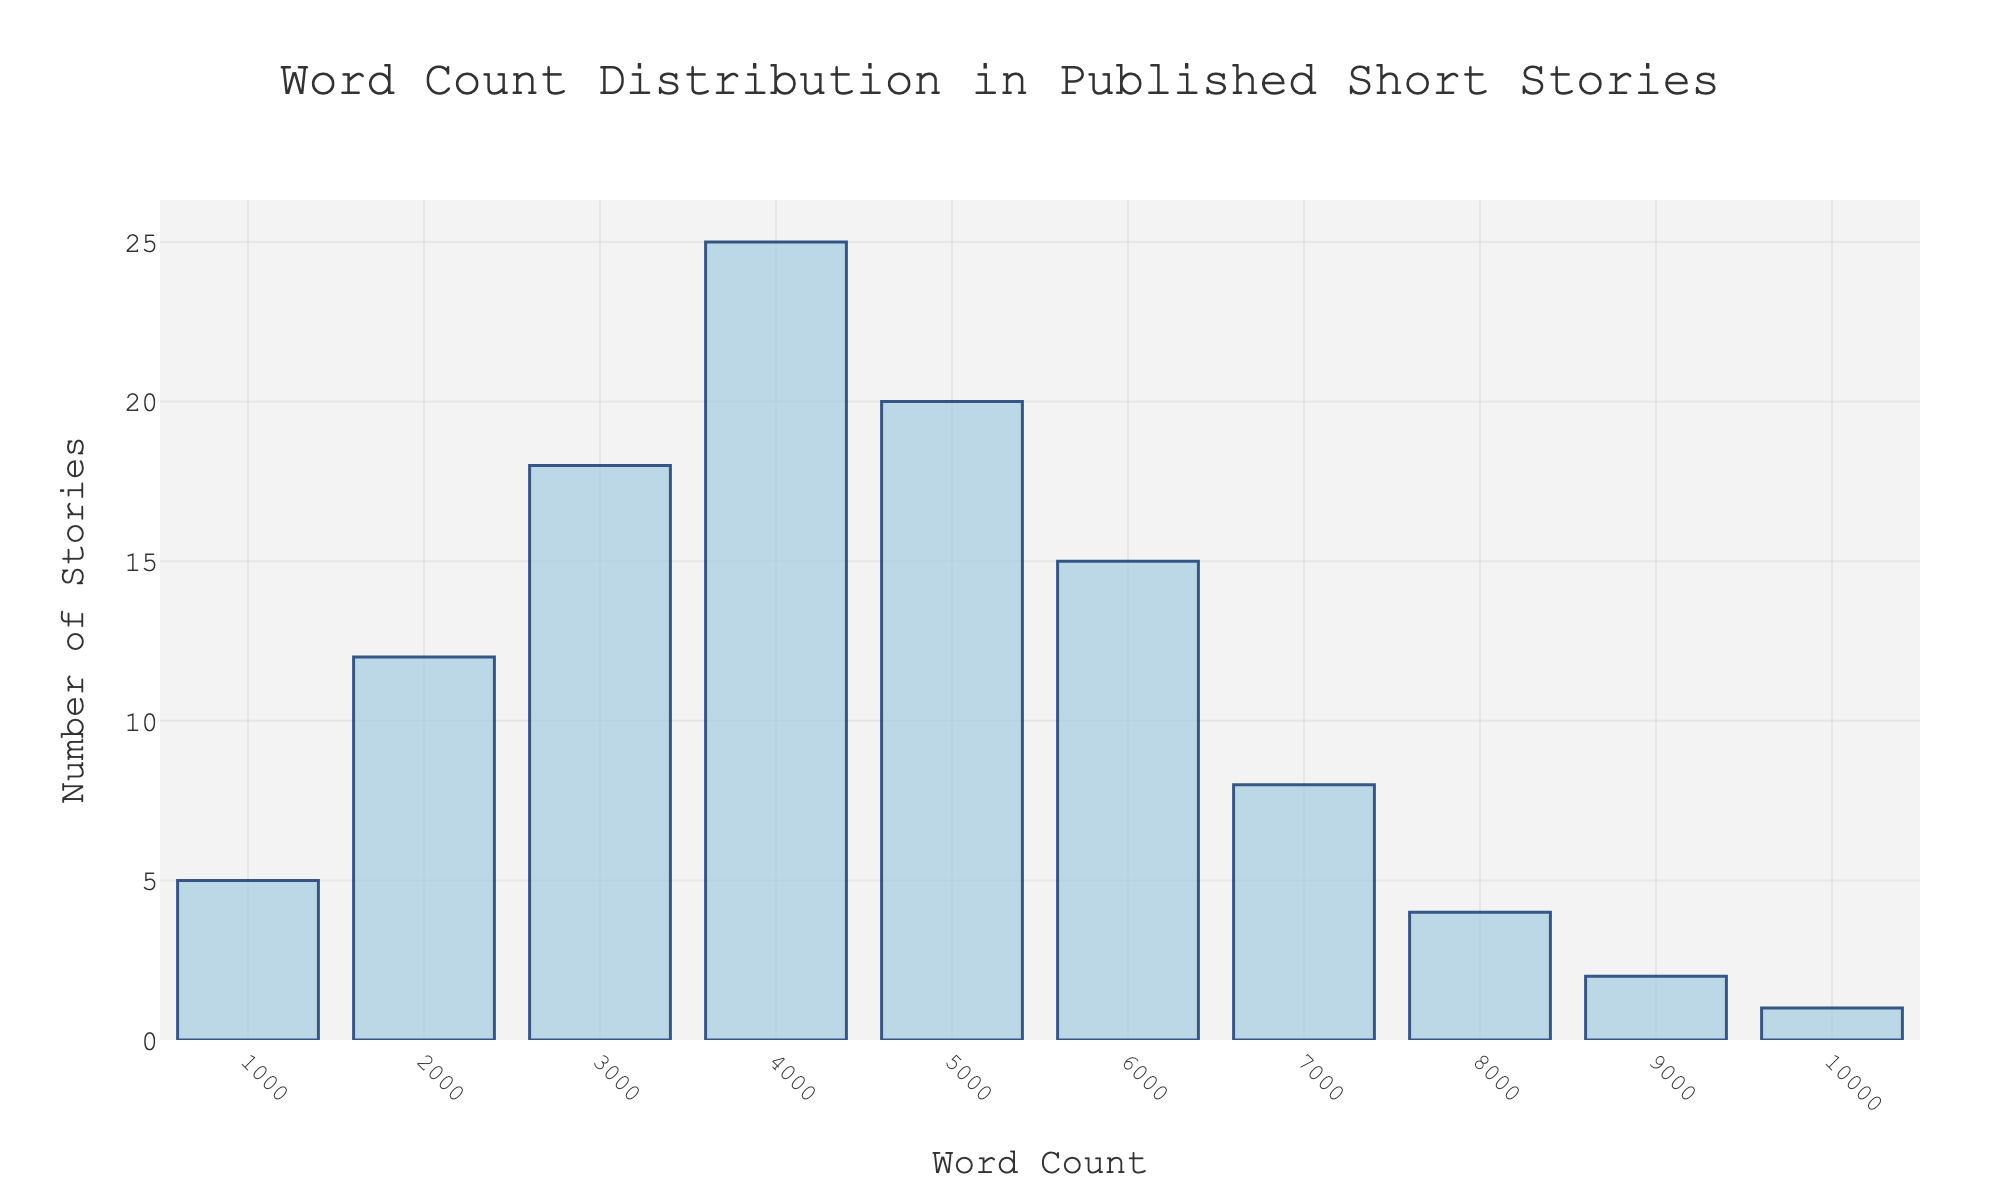What is the title of the figure? The title of the figure is usually located at the top of the chart and often gives a summary of what the figure represents. By looking there, we can see that the figure's title explains that it is about the distribution of word counts in published short stories.
Answer: Word Count Distribution in Published Short Stories How many short stories have word counts between 3001 and 4000? To find this information, locate the bar corresponding to the 3001-4000 word count range on the x-axis and then look at the height of the bar to see the number of stories.
Answer: 25 Which word count range has the least number of short stories? By examining the heights of all the bars, identify the shortest bar. The corresponding word count range for that bar reveals the range with the least number of stories.
Answer: 9001-10000 What is the total number of short stories with word counts less than 5000? Sum the number of stories for each word count range that is less than 5000. Specifically, add the values for the ranges 0-1000, 1001-2000, 2001-3000, 3001-4000, and 4001-5000.
Answer: 80 In which word count range do the majority of short stories fall? Identify the bar with the highest height, which indicates the word count range with the most stories.
Answer: 3001-4000 How does the number of short stories between 5001-6000 compare to the number between 4001-5000? Compare the heights of the bars representing the ranges 5001-6000 and 4001-5000. The range with the higher bar has the greater number of stories.
Answer: The 4001-5000 range has more stories What is the proportion of short stories with word counts between 3001 and 6000 relative to the total number of stories? First, sum the number of stories in the ranges 3001-4000, 4001-5000, and 5001-6000. Then find the total number of stories by adding the values of all ranges. Finally, divide the sum for the specified ranges by the total number and multiply by 100 to get the percentage.
Answer: 60% Which word count range shows a visible decrease in the number of short stories compared to the previous range? Check each subsequent pair of bars to identify where there is a decrease in height.
Answer: 7001-8000 compared to 6001-7000 How would you describe the trend in the number of short stories as the word count increases? Observe the general pattern of the bar heights from left to right. A trend describes whether the number of stories increases, decreases, or stays constant as the word count increases.
Answer: Generally decreasing What is the meaning of the icons over the bars in the figure? The icons are placed above the bars to visually represent stories. Each icon likely symbolizes an individual story or group of stories.
Answer: They represent short stories 